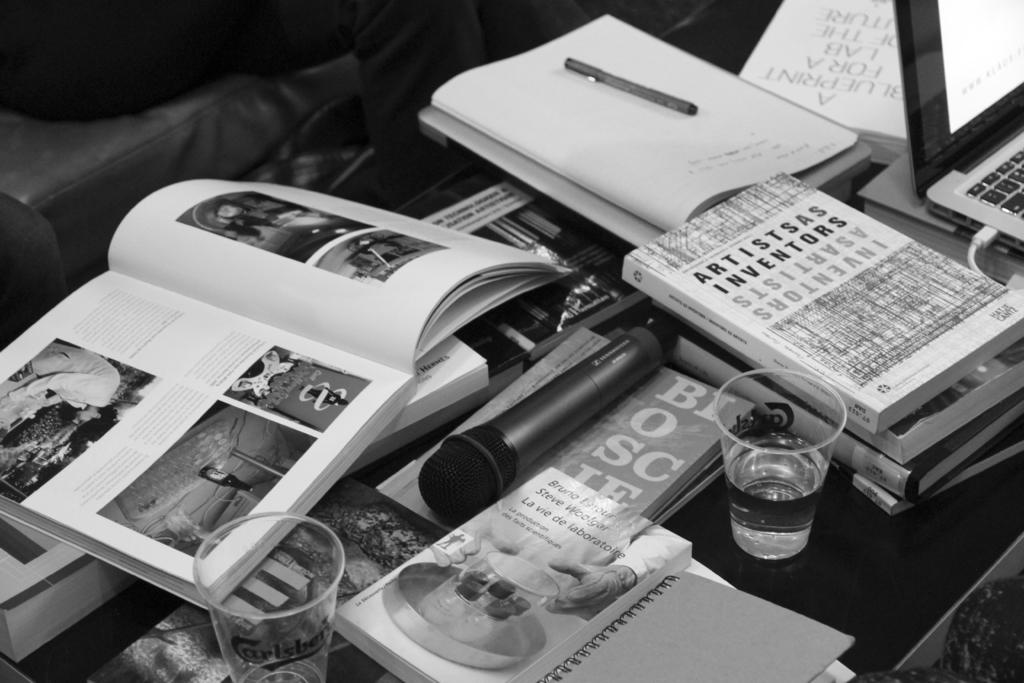What is the color scheme of the image? The image is black and white. What type of objects can be seen on the table in the image? There are many books, a laptop, a glass, and a mic in the image. What might be used for typing or browsing in the image? The laptop in the image can be used for typing or browsing. What is the purpose of the glass in the image? The purpose of the glass in the image is not specified, but it could be used for drinking or holding objects. How many dolls are sitting on the table in the image? There are no dolls present in the image; it only features books, a laptop, a glass, and a mic on a table. What type of bubble is floating in the image? There is no bubble present in the image. 